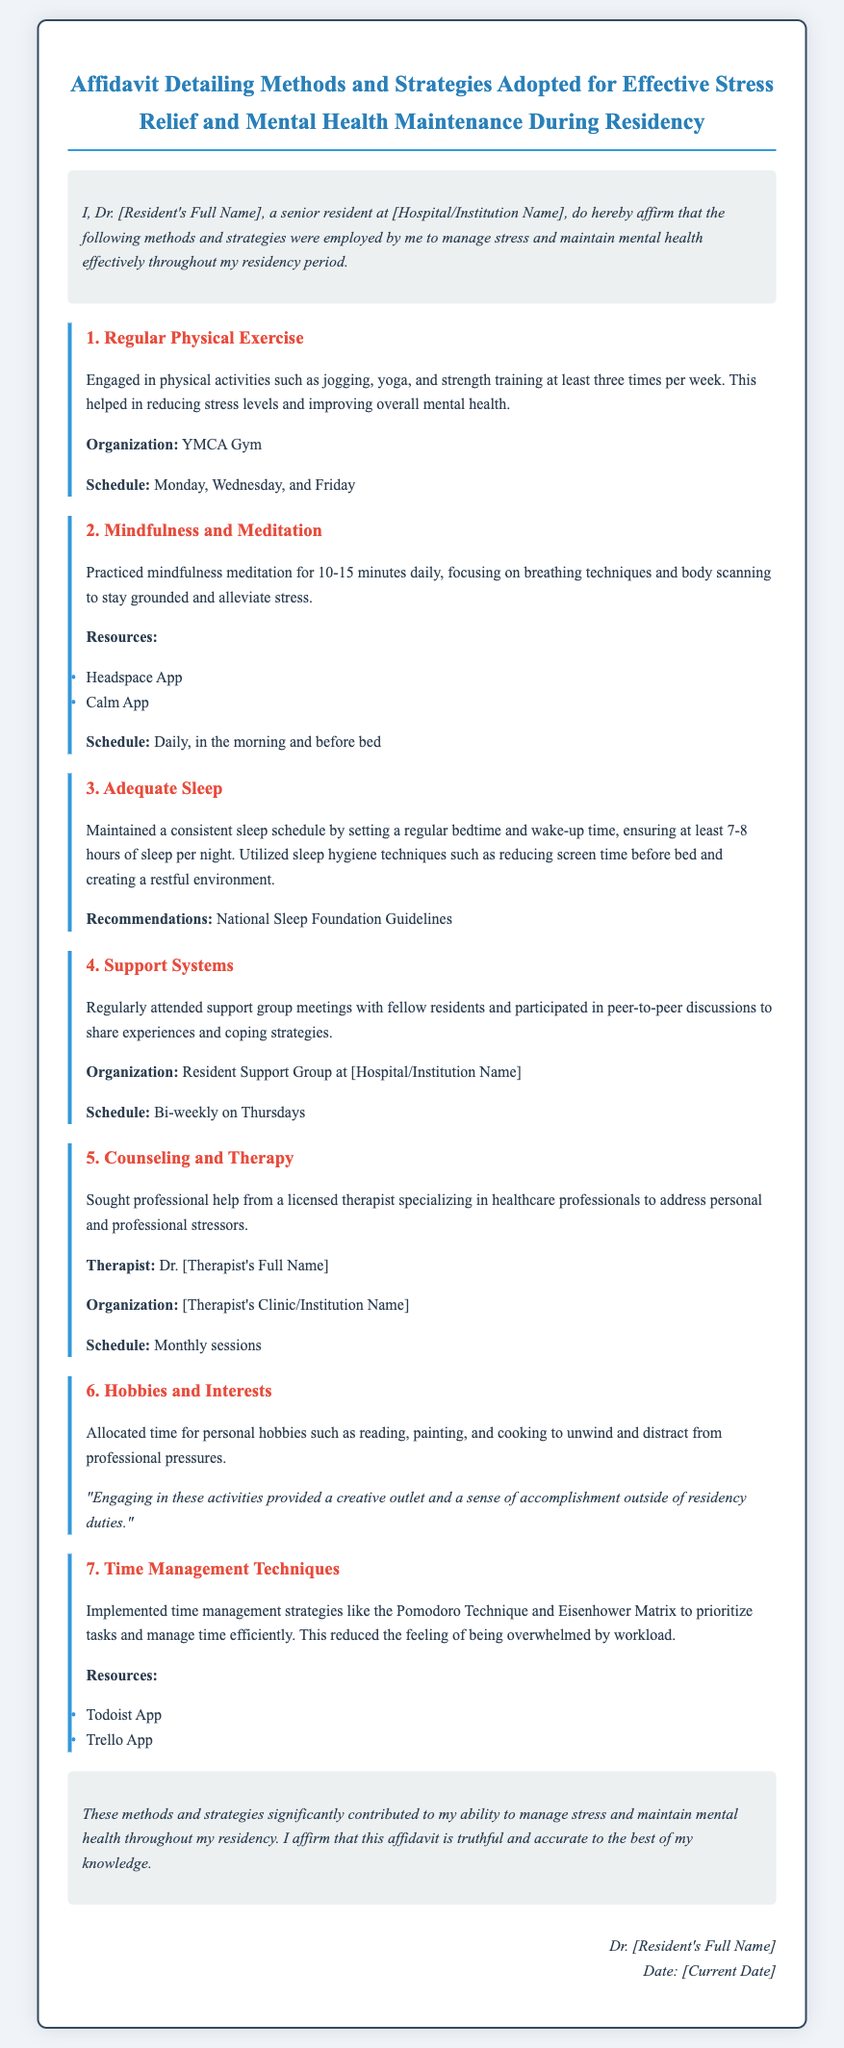What is the resident's full name? The document indicates a placeholder for the resident's full name, which should be provided in the affidavit.
Answer: Dr. [Resident's Full Name] What is the organization for physical exercise? The affidavit mentions the organization where the resident engages in physical activities.
Answer: YMCA Gym How often is mindfulness meditation practiced? The document specifies the frequency of mindfulness meditation sessions in the residency.
Answer: Daily What is the scheduled time for support group meetings? The affidavit includes the frequency of support group meetings established by the resident.
Answer: Bi-weekly on Thursdays What type of therapy was sought by the resident? The affidavit states the nature of professional help the resident accessed for managing stress.
Answer: Counseling and Therapy How many hours of sleep does the resident aim for each night? The document mentions the target amount of sleep the resident strives to achieve.
Answer: 7-8 hours What technique is used for time management? The affidavit lists specific time management strategy that the resident implemented.
Answer: Pomodoro Technique What is the main benefit of engaging in hobbies? The document highlights the overarching advantage of pursuing personal interests outside of residency.
Answer: Creative outlet 